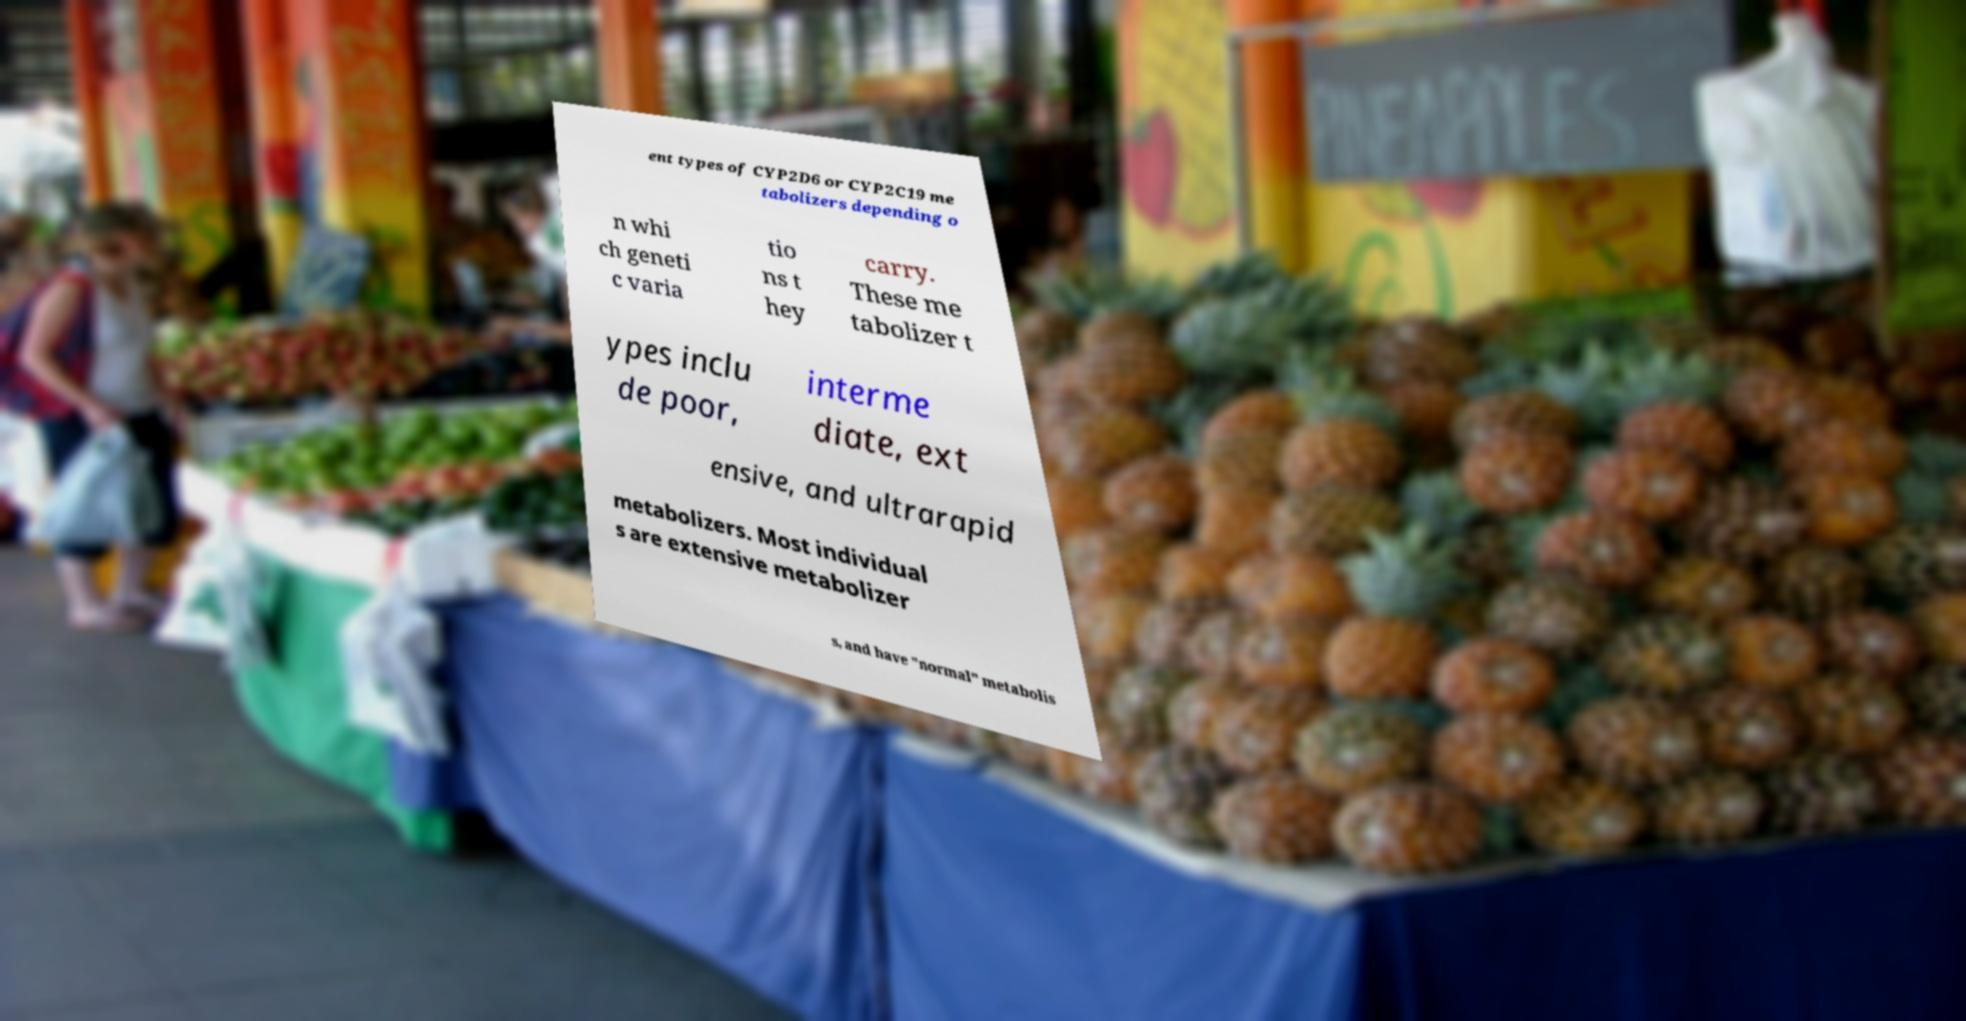I need the written content from this picture converted into text. Can you do that? ent types of CYP2D6 or CYP2C19 me tabolizers depending o n whi ch geneti c varia tio ns t hey carry. These me tabolizer t ypes inclu de poor, interme diate, ext ensive, and ultrarapid metabolizers. Most individual s are extensive metabolizer s, and have "normal" metabolis 